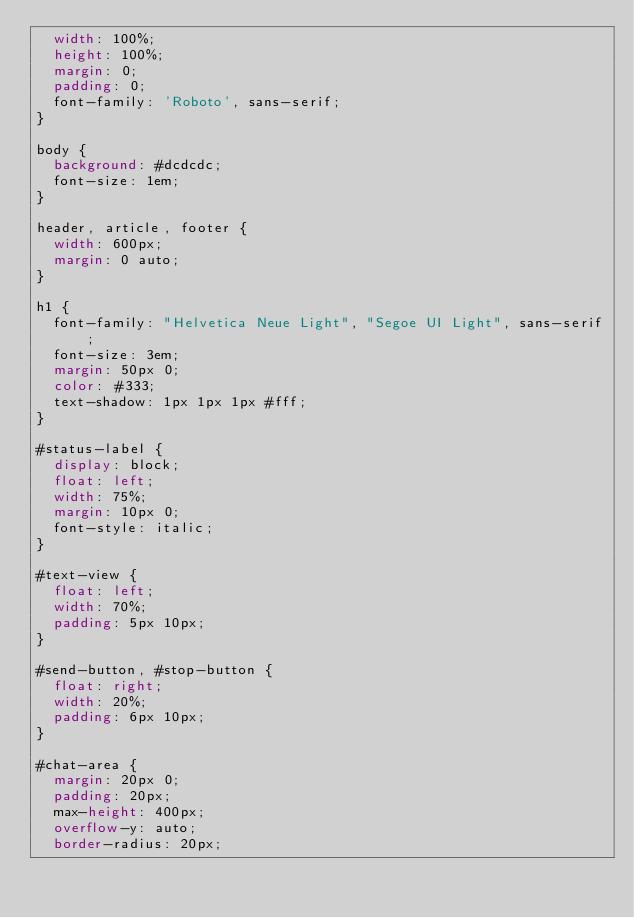Convert code to text. <code><loc_0><loc_0><loc_500><loc_500><_CSS_>  width: 100%;
  height: 100%;
  margin: 0;
  padding: 0;
  font-family: 'Roboto', sans-serif;
}

body {
  background: #dcdcdc;
  font-size: 1em;
}

header, article, footer {
  width: 600px;
  margin: 0 auto;
}

h1 {
  font-family: "Helvetica Neue Light", "Segoe UI Light", sans-serif;
  font-size: 3em;
  margin: 50px 0;
  color: #333;
  text-shadow: 1px 1px 1px #fff;
}

#status-label {
  display: block;
  float: left;
  width: 75%;
  margin: 10px 0;
  font-style: italic;
}

#text-view {
  float: left;
  width: 70%;
  padding: 5px 10px;
}

#send-button, #stop-button {
  float: right;
  width: 20%;
  padding: 6px 10px;
}

#chat-area {
  margin: 20px 0;
  padding: 20px;
  max-height: 400px;
  overflow-y: auto;
  border-radius: 20px;</code> 